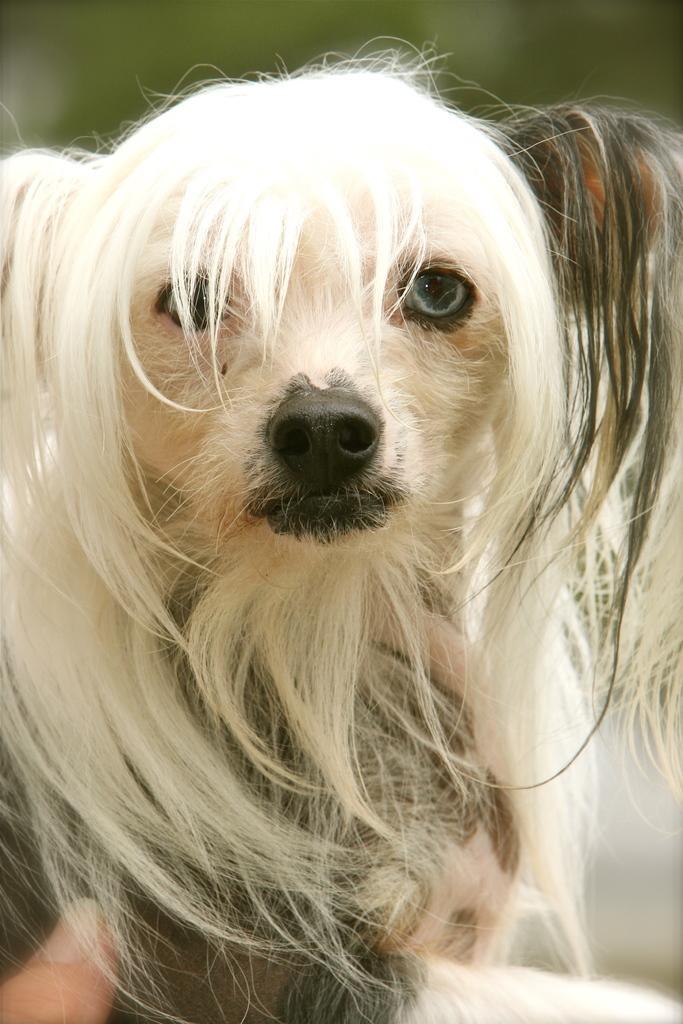How would you summarize this image in a sentence or two? This picture is mainly highlighted with a dog. In the bottom left corner of the picture we can see a person's thumb. 